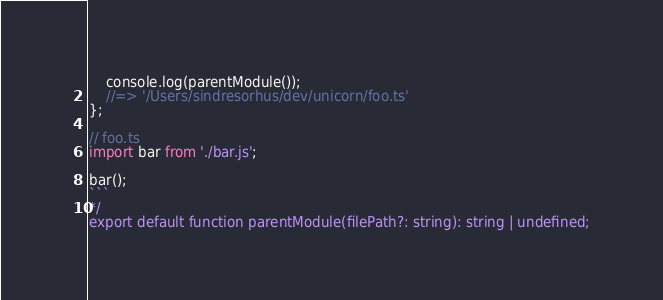Convert code to text. <code><loc_0><loc_0><loc_500><loc_500><_TypeScript_>	console.log(parentModule());
	//=> '/Users/sindresorhus/dev/unicorn/foo.ts'
};

// foo.ts
import bar from './bar.js';

bar();
```
*/
export default function parentModule(filePath?: string): string | undefined;
</code> 